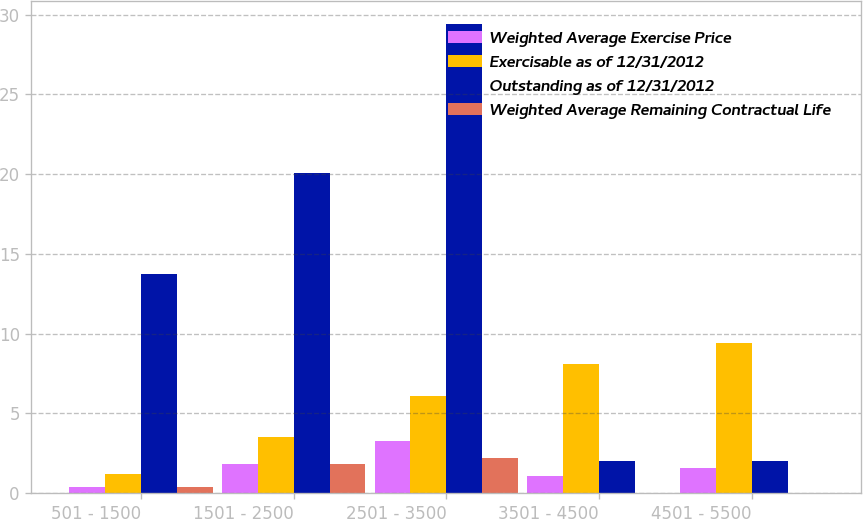Convert chart to OTSL. <chart><loc_0><loc_0><loc_500><loc_500><stacked_bar_chart><ecel><fcel>501 - 1500<fcel>1501 - 2500<fcel>2501 - 3500<fcel>3501 - 4500<fcel>4501 - 5500<nl><fcel>Weighted Average Exercise Price<fcel>0.4<fcel>1.8<fcel>3.3<fcel>1.1<fcel>1.6<nl><fcel>Exercisable as of 12/31/2012<fcel>1.2<fcel>3.5<fcel>6.1<fcel>8.1<fcel>9.4<nl><fcel>Outstanding as of 12/31/2012<fcel>13.73<fcel>20.06<fcel>29.39<fcel>2<fcel>2<nl><fcel>Weighted Average Remaining Contractual Life<fcel>0.4<fcel>1.8<fcel>2.2<fcel>0<fcel>0<nl></chart> 